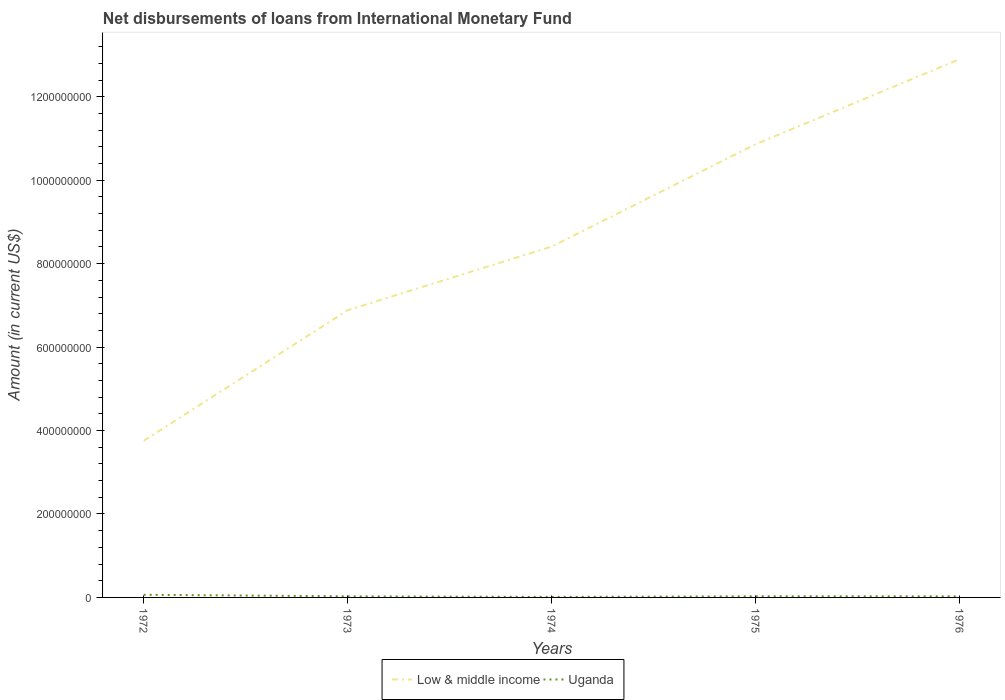Does the line corresponding to Low & middle income intersect with the line corresponding to Uganda?
Offer a terse response. No. Is the number of lines equal to the number of legend labels?
Your answer should be very brief. Yes. Across all years, what is the maximum amount of loans disbursed in Uganda?
Make the answer very short. 1.16e+06. In which year was the amount of loans disbursed in Uganda maximum?
Provide a short and direct response. 1974. What is the total amount of loans disbursed in Low & middle income in the graph?
Offer a terse response. -1.53e+08. What is the difference between the highest and the second highest amount of loans disbursed in Low & middle income?
Give a very brief answer. 9.15e+08. What is the difference between the highest and the lowest amount of loans disbursed in Uganda?
Provide a short and direct response. 1. Is the amount of loans disbursed in Uganda strictly greater than the amount of loans disbursed in Low & middle income over the years?
Offer a terse response. Yes. Where does the legend appear in the graph?
Provide a succinct answer. Bottom center. How are the legend labels stacked?
Offer a terse response. Horizontal. What is the title of the graph?
Keep it short and to the point. Net disbursements of loans from International Monetary Fund. Does "Bahrain" appear as one of the legend labels in the graph?
Offer a terse response. No. What is the label or title of the Y-axis?
Your response must be concise. Amount (in current US$). What is the Amount (in current US$) in Low & middle income in 1972?
Provide a short and direct response. 3.75e+08. What is the Amount (in current US$) of Uganda in 1972?
Keep it short and to the point. 6.34e+06. What is the Amount (in current US$) in Low & middle income in 1973?
Provide a succinct answer. 6.88e+08. What is the Amount (in current US$) in Uganda in 1973?
Your response must be concise. 2.68e+06. What is the Amount (in current US$) of Low & middle income in 1974?
Provide a short and direct response. 8.41e+08. What is the Amount (in current US$) of Uganda in 1974?
Give a very brief answer. 1.16e+06. What is the Amount (in current US$) of Low & middle income in 1975?
Your answer should be compact. 1.09e+09. What is the Amount (in current US$) in Uganda in 1975?
Provide a succinct answer. 2.76e+06. What is the Amount (in current US$) of Low & middle income in 1976?
Offer a very short reply. 1.29e+09. What is the Amount (in current US$) of Uganda in 1976?
Your answer should be compact. 2.66e+06. Across all years, what is the maximum Amount (in current US$) in Low & middle income?
Keep it short and to the point. 1.29e+09. Across all years, what is the maximum Amount (in current US$) of Uganda?
Your answer should be compact. 6.34e+06. Across all years, what is the minimum Amount (in current US$) of Low & middle income?
Provide a succinct answer. 3.75e+08. Across all years, what is the minimum Amount (in current US$) in Uganda?
Ensure brevity in your answer.  1.16e+06. What is the total Amount (in current US$) in Low & middle income in the graph?
Offer a terse response. 4.28e+09. What is the total Amount (in current US$) of Uganda in the graph?
Your answer should be very brief. 1.56e+07. What is the difference between the Amount (in current US$) of Low & middle income in 1972 and that in 1973?
Offer a very short reply. -3.13e+08. What is the difference between the Amount (in current US$) in Uganda in 1972 and that in 1973?
Your response must be concise. 3.65e+06. What is the difference between the Amount (in current US$) in Low & middle income in 1972 and that in 1974?
Make the answer very short. -4.66e+08. What is the difference between the Amount (in current US$) of Uganda in 1972 and that in 1974?
Provide a short and direct response. 5.17e+06. What is the difference between the Amount (in current US$) of Low & middle income in 1972 and that in 1975?
Provide a short and direct response. -7.11e+08. What is the difference between the Amount (in current US$) in Uganda in 1972 and that in 1975?
Give a very brief answer. 3.58e+06. What is the difference between the Amount (in current US$) of Low & middle income in 1972 and that in 1976?
Make the answer very short. -9.15e+08. What is the difference between the Amount (in current US$) of Uganda in 1972 and that in 1976?
Your answer should be very brief. 3.68e+06. What is the difference between the Amount (in current US$) in Low & middle income in 1973 and that in 1974?
Ensure brevity in your answer.  -1.53e+08. What is the difference between the Amount (in current US$) in Uganda in 1973 and that in 1974?
Provide a short and direct response. 1.52e+06. What is the difference between the Amount (in current US$) in Low & middle income in 1973 and that in 1975?
Offer a terse response. -3.98e+08. What is the difference between the Amount (in current US$) of Uganda in 1973 and that in 1975?
Your answer should be very brief. -7.40e+04. What is the difference between the Amount (in current US$) in Low & middle income in 1973 and that in 1976?
Provide a succinct answer. -6.02e+08. What is the difference between the Amount (in current US$) in Uganda in 1973 and that in 1976?
Offer a very short reply. 2.50e+04. What is the difference between the Amount (in current US$) in Low & middle income in 1974 and that in 1975?
Your response must be concise. -2.45e+08. What is the difference between the Amount (in current US$) in Uganda in 1974 and that in 1975?
Your response must be concise. -1.59e+06. What is the difference between the Amount (in current US$) of Low & middle income in 1974 and that in 1976?
Make the answer very short. -4.49e+08. What is the difference between the Amount (in current US$) in Uganda in 1974 and that in 1976?
Your response must be concise. -1.50e+06. What is the difference between the Amount (in current US$) of Low & middle income in 1975 and that in 1976?
Provide a succinct answer. -2.04e+08. What is the difference between the Amount (in current US$) in Uganda in 1975 and that in 1976?
Keep it short and to the point. 9.90e+04. What is the difference between the Amount (in current US$) in Low & middle income in 1972 and the Amount (in current US$) in Uganda in 1973?
Your answer should be very brief. 3.73e+08. What is the difference between the Amount (in current US$) of Low & middle income in 1972 and the Amount (in current US$) of Uganda in 1974?
Provide a short and direct response. 3.74e+08. What is the difference between the Amount (in current US$) of Low & middle income in 1972 and the Amount (in current US$) of Uganda in 1975?
Your response must be concise. 3.73e+08. What is the difference between the Amount (in current US$) of Low & middle income in 1972 and the Amount (in current US$) of Uganda in 1976?
Give a very brief answer. 3.73e+08. What is the difference between the Amount (in current US$) in Low & middle income in 1973 and the Amount (in current US$) in Uganda in 1974?
Keep it short and to the point. 6.87e+08. What is the difference between the Amount (in current US$) in Low & middle income in 1973 and the Amount (in current US$) in Uganda in 1975?
Your response must be concise. 6.86e+08. What is the difference between the Amount (in current US$) of Low & middle income in 1973 and the Amount (in current US$) of Uganda in 1976?
Your answer should be very brief. 6.86e+08. What is the difference between the Amount (in current US$) of Low & middle income in 1974 and the Amount (in current US$) of Uganda in 1975?
Give a very brief answer. 8.38e+08. What is the difference between the Amount (in current US$) of Low & middle income in 1974 and the Amount (in current US$) of Uganda in 1976?
Provide a short and direct response. 8.38e+08. What is the difference between the Amount (in current US$) of Low & middle income in 1975 and the Amount (in current US$) of Uganda in 1976?
Your answer should be compact. 1.08e+09. What is the average Amount (in current US$) of Low & middle income per year?
Offer a very short reply. 8.56e+08. What is the average Amount (in current US$) of Uganda per year?
Offer a terse response. 3.12e+06. In the year 1972, what is the difference between the Amount (in current US$) in Low & middle income and Amount (in current US$) in Uganda?
Provide a succinct answer. 3.69e+08. In the year 1973, what is the difference between the Amount (in current US$) of Low & middle income and Amount (in current US$) of Uganda?
Your answer should be compact. 6.86e+08. In the year 1974, what is the difference between the Amount (in current US$) in Low & middle income and Amount (in current US$) in Uganda?
Your answer should be compact. 8.40e+08. In the year 1975, what is the difference between the Amount (in current US$) in Low & middle income and Amount (in current US$) in Uganda?
Make the answer very short. 1.08e+09. In the year 1976, what is the difference between the Amount (in current US$) of Low & middle income and Amount (in current US$) of Uganda?
Ensure brevity in your answer.  1.29e+09. What is the ratio of the Amount (in current US$) in Low & middle income in 1972 to that in 1973?
Keep it short and to the point. 0.55. What is the ratio of the Amount (in current US$) of Uganda in 1972 to that in 1973?
Your answer should be very brief. 2.36. What is the ratio of the Amount (in current US$) of Low & middle income in 1972 to that in 1974?
Offer a very short reply. 0.45. What is the ratio of the Amount (in current US$) in Uganda in 1972 to that in 1974?
Offer a terse response. 5.44. What is the ratio of the Amount (in current US$) of Low & middle income in 1972 to that in 1975?
Keep it short and to the point. 0.35. What is the ratio of the Amount (in current US$) in Uganda in 1972 to that in 1975?
Keep it short and to the point. 2.3. What is the ratio of the Amount (in current US$) in Low & middle income in 1972 to that in 1976?
Provide a succinct answer. 0.29. What is the ratio of the Amount (in current US$) of Uganda in 1972 to that in 1976?
Make the answer very short. 2.38. What is the ratio of the Amount (in current US$) of Low & middle income in 1973 to that in 1974?
Keep it short and to the point. 0.82. What is the ratio of the Amount (in current US$) in Uganda in 1973 to that in 1974?
Offer a very short reply. 2.31. What is the ratio of the Amount (in current US$) in Low & middle income in 1973 to that in 1975?
Give a very brief answer. 0.63. What is the ratio of the Amount (in current US$) of Uganda in 1973 to that in 1975?
Your answer should be compact. 0.97. What is the ratio of the Amount (in current US$) in Low & middle income in 1973 to that in 1976?
Your answer should be very brief. 0.53. What is the ratio of the Amount (in current US$) in Uganda in 1973 to that in 1976?
Make the answer very short. 1.01. What is the ratio of the Amount (in current US$) of Low & middle income in 1974 to that in 1975?
Offer a very short reply. 0.77. What is the ratio of the Amount (in current US$) in Uganda in 1974 to that in 1975?
Provide a succinct answer. 0.42. What is the ratio of the Amount (in current US$) of Low & middle income in 1974 to that in 1976?
Give a very brief answer. 0.65. What is the ratio of the Amount (in current US$) in Uganda in 1974 to that in 1976?
Your response must be concise. 0.44. What is the ratio of the Amount (in current US$) of Low & middle income in 1975 to that in 1976?
Your answer should be compact. 0.84. What is the ratio of the Amount (in current US$) in Uganda in 1975 to that in 1976?
Your answer should be very brief. 1.04. What is the difference between the highest and the second highest Amount (in current US$) in Low & middle income?
Give a very brief answer. 2.04e+08. What is the difference between the highest and the second highest Amount (in current US$) in Uganda?
Offer a terse response. 3.58e+06. What is the difference between the highest and the lowest Amount (in current US$) in Low & middle income?
Give a very brief answer. 9.15e+08. What is the difference between the highest and the lowest Amount (in current US$) in Uganda?
Offer a very short reply. 5.17e+06. 